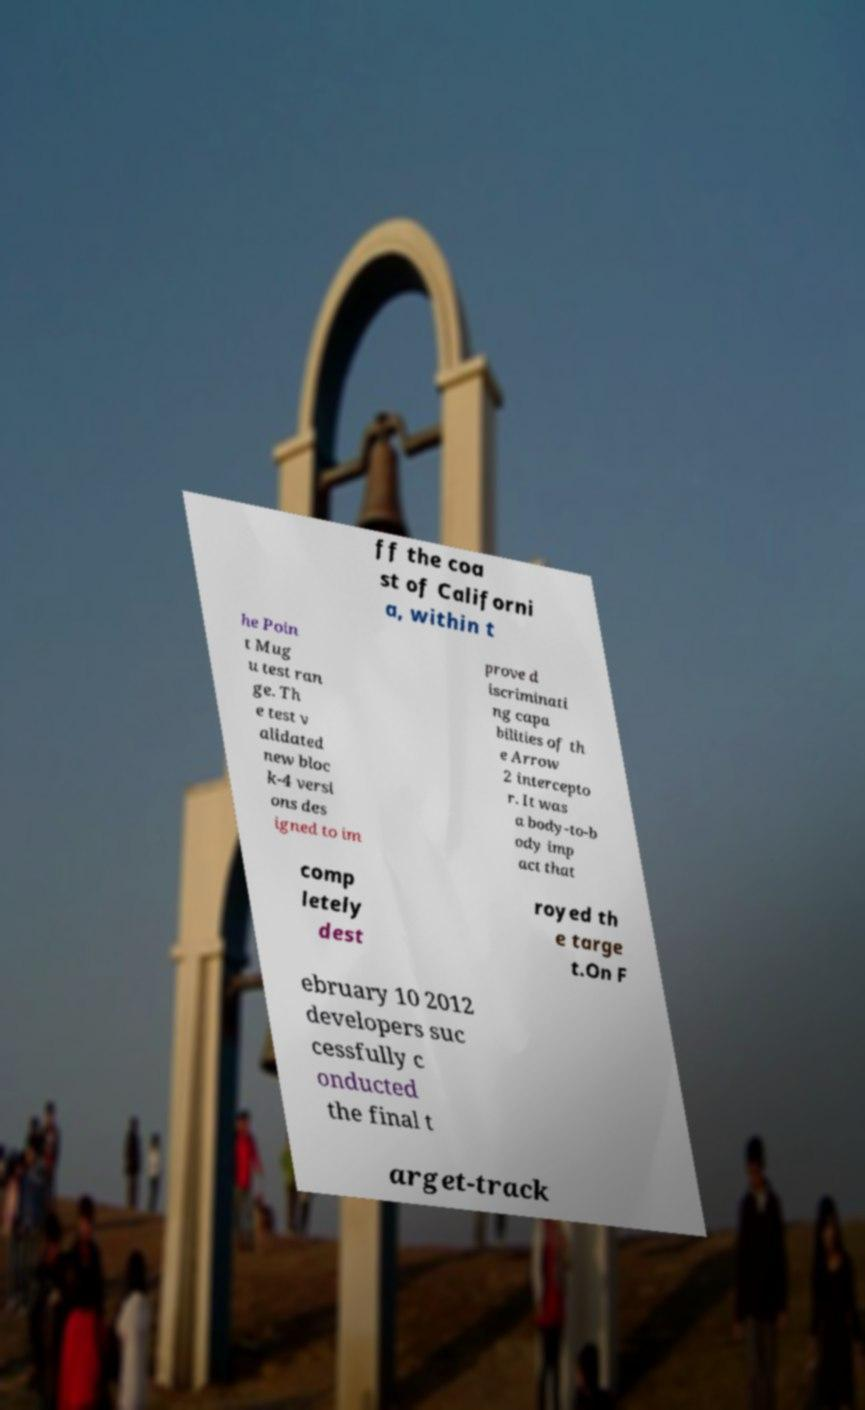What messages or text are displayed in this image? I need them in a readable, typed format. ff the coa st of Californi a, within t he Poin t Mug u test ran ge. Th e test v alidated new bloc k-4 versi ons des igned to im prove d iscriminati ng capa bilities of th e Arrow 2 intercepto r. It was a body-to-b ody imp act that comp letely dest royed th e targe t.On F ebruary 10 2012 developers suc cessfully c onducted the final t arget-track 